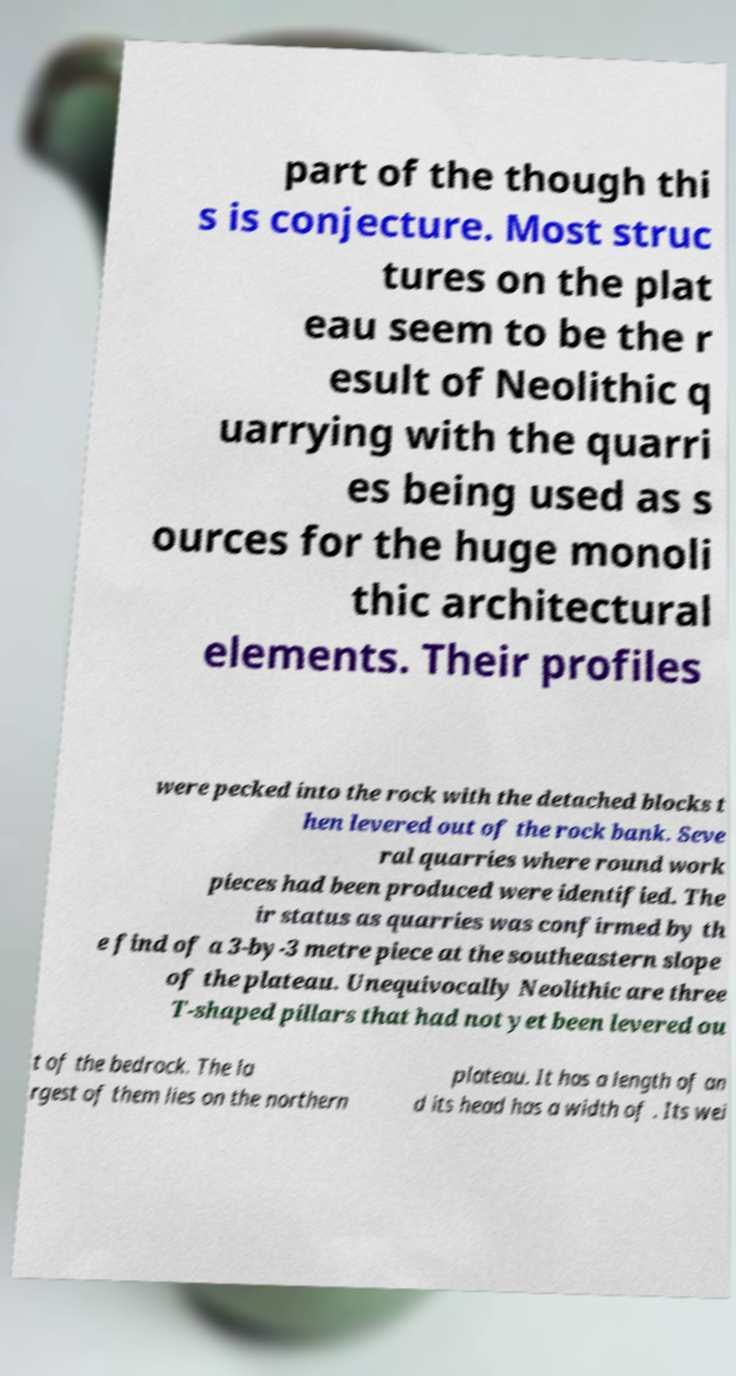There's text embedded in this image that I need extracted. Can you transcribe it verbatim? part of the though thi s is conjecture. Most struc tures on the plat eau seem to be the r esult of Neolithic q uarrying with the quarri es being used as s ources for the huge monoli thic architectural elements. Their profiles were pecked into the rock with the detached blocks t hen levered out of the rock bank. Seve ral quarries where round work pieces had been produced were identified. The ir status as quarries was confirmed by th e find of a 3-by-3 metre piece at the southeastern slope of the plateau. Unequivocally Neolithic are three T-shaped pillars that had not yet been levered ou t of the bedrock. The la rgest of them lies on the northern plateau. It has a length of an d its head has a width of . Its wei 